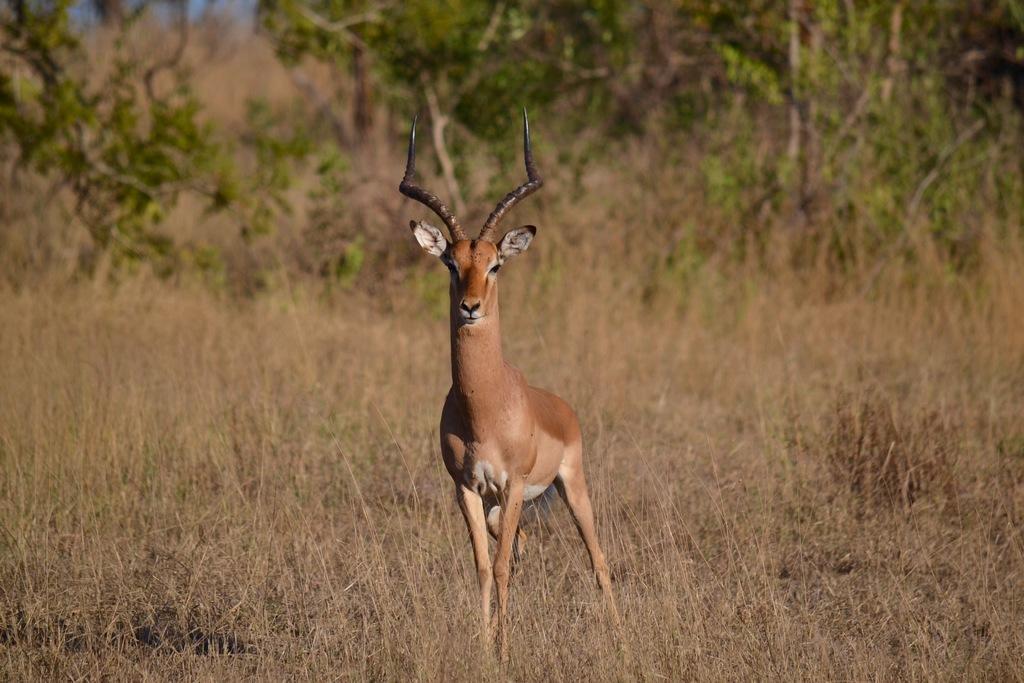How would you summarize this image in a sentence or two? In this image there is a deer standing on the grassland. Background there are trees. 